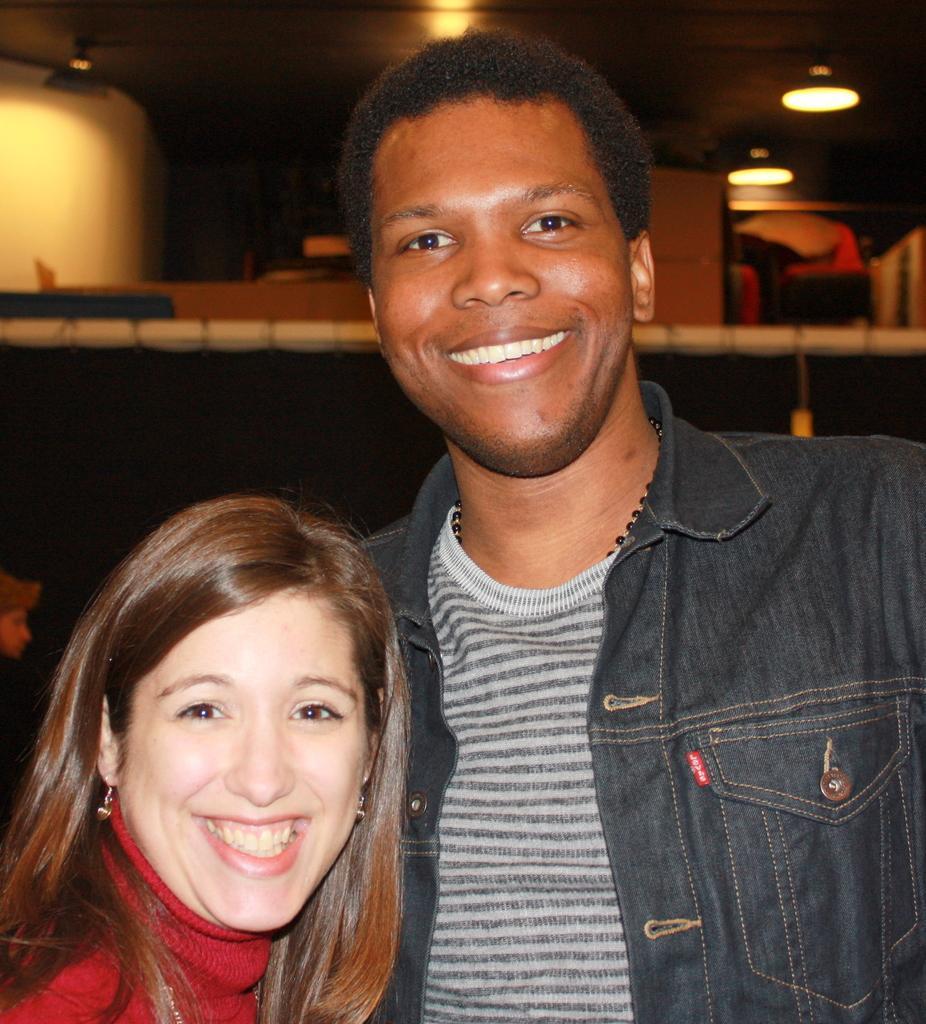How would you summarize this image in a sentence or two? In this picture I can see in the middle a man and a woman are smiling, in the background there are ceiling lights. 